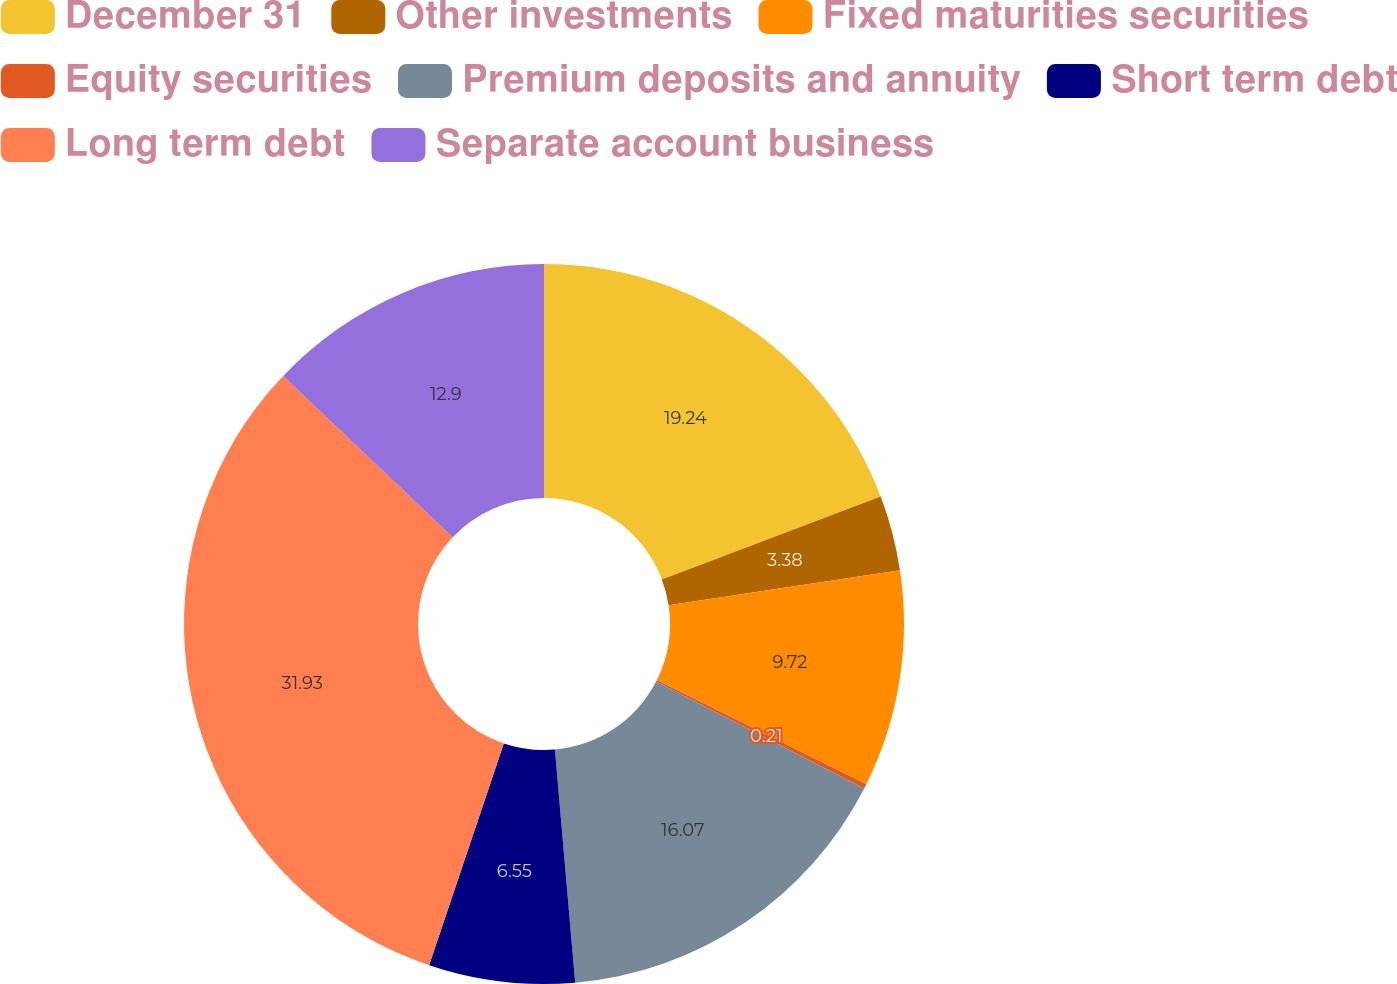Convert chart to OTSL. <chart><loc_0><loc_0><loc_500><loc_500><pie_chart><fcel>December 31<fcel>Other investments<fcel>Fixed maturities securities<fcel>Equity securities<fcel>Premium deposits and annuity<fcel>Short term debt<fcel>Long term debt<fcel>Separate account business<nl><fcel>19.24%<fcel>3.38%<fcel>9.72%<fcel>0.21%<fcel>16.07%<fcel>6.55%<fcel>31.93%<fcel>12.9%<nl></chart> 